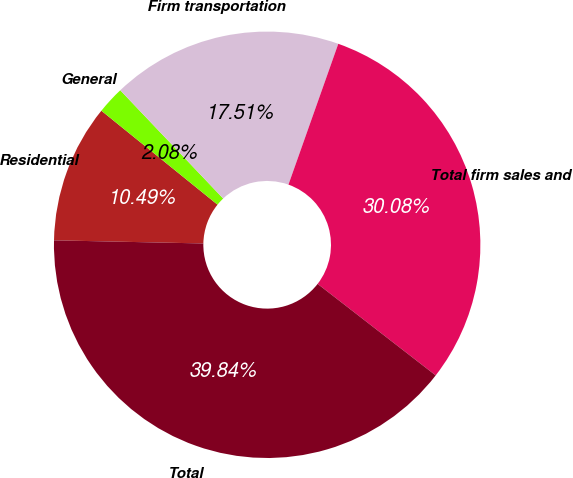Convert chart. <chart><loc_0><loc_0><loc_500><loc_500><pie_chart><fcel>Residential<fcel>General<fcel>Firm transportation<fcel>Total firm sales and<fcel>Total<nl><fcel>10.49%<fcel>2.08%<fcel>17.51%<fcel>30.08%<fcel>39.84%<nl></chart> 